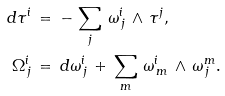<formula> <loc_0><loc_0><loc_500><loc_500>d \tau ^ { i } \, & = \, - \, \sum _ { j } \, \omega ^ { i } _ { \, j } \, \wedge \, \tau ^ { j } , \\ \Omega ^ { i } _ { \, j } \, & = \, d \omega ^ { i } _ { \, j } \, + \, \sum _ { m } \, \omega ^ { i } _ { \, m } \, \wedge \, \omega ^ { m } _ { \, j } .</formula> 